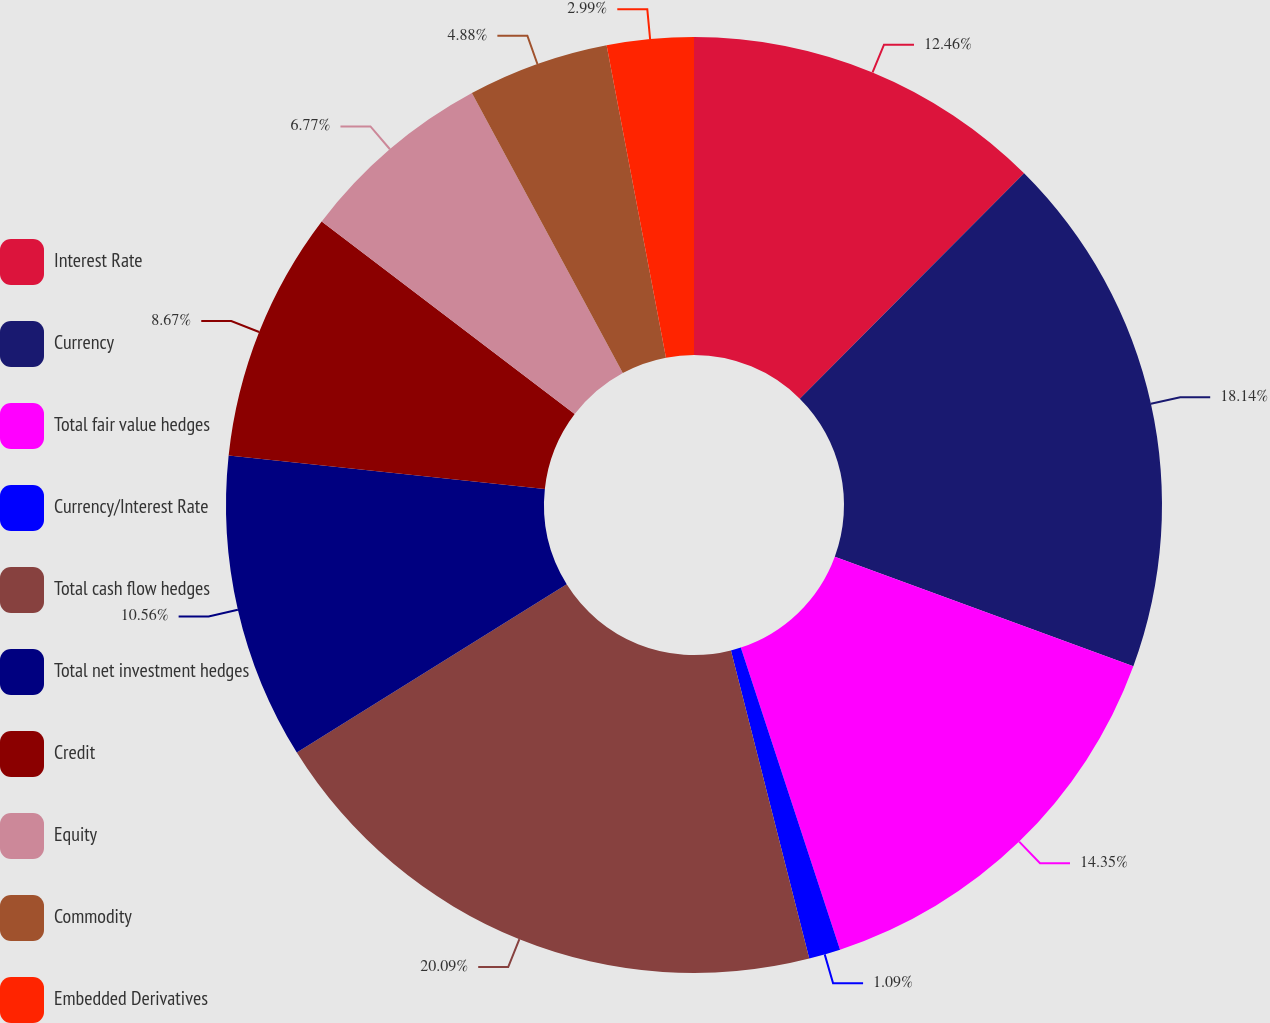Convert chart to OTSL. <chart><loc_0><loc_0><loc_500><loc_500><pie_chart><fcel>Interest Rate<fcel>Currency<fcel>Total fair value hedges<fcel>Currency/Interest Rate<fcel>Total cash flow hedges<fcel>Total net investment hedges<fcel>Credit<fcel>Equity<fcel>Commodity<fcel>Embedded Derivatives<nl><fcel>12.46%<fcel>18.14%<fcel>14.35%<fcel>1.09%<fcel>20.09%<fcel>10.56%<fcel>8.67%<fcel>6.77%<fcel>4.88%<fcel>2.99%<nl></chart> 